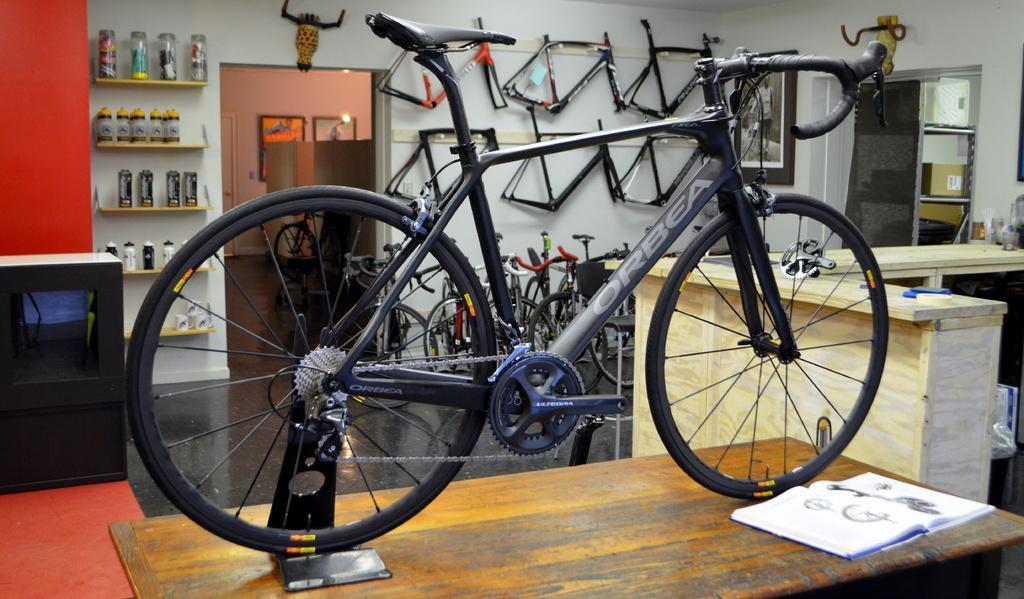Describe this image in one or two sentences. In this image we can see a bicycle and book kept on the table. In the background we can see some cylindrical objects in the cupboards, spare parts hanged to the wall, photo frames and bicycles placed on the floor. 